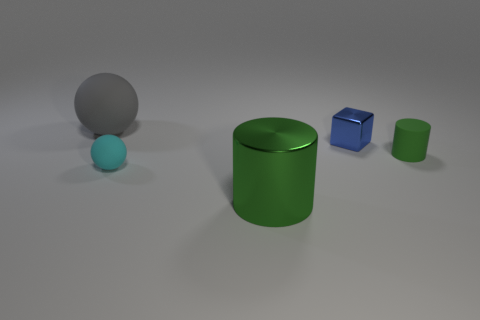Do the cylinder on the left side of the small blue block and the rubber object to the right of the cyan matte object have the same color?
Give a very brief answer. Yes. There is a tiny rubber object that is the same color as the large shiny thing; what is its shape?
Your response must be concise. Cylinder. What size is the blue shiny block?
Keep it short and to the point. Small. Are there any small objects that have the same shape as the big matte thing?
Your answer should be very brief. Yes. What number of things are either purple matte things or matte things right of the gray matte sphere?
Make the answer very short. 2. There is a matte object that is to the left of the cyan thing; what is its color?
Make the answer very short. Gray. Is the size of the object that is right of the cube the same as the metal thing in front of the small rubber cylinder?
Provide a succinct answer. No. Is there a red metal cylinder of the same size as the cyan rubber object?
Keep it short and to the point. No. There is a metal thing in front of the small shiny thing; how many rubber objects are left of it?
Make the answer very short. 2. What material is the big gray object?
Your answer should be very brief. Rubber. 